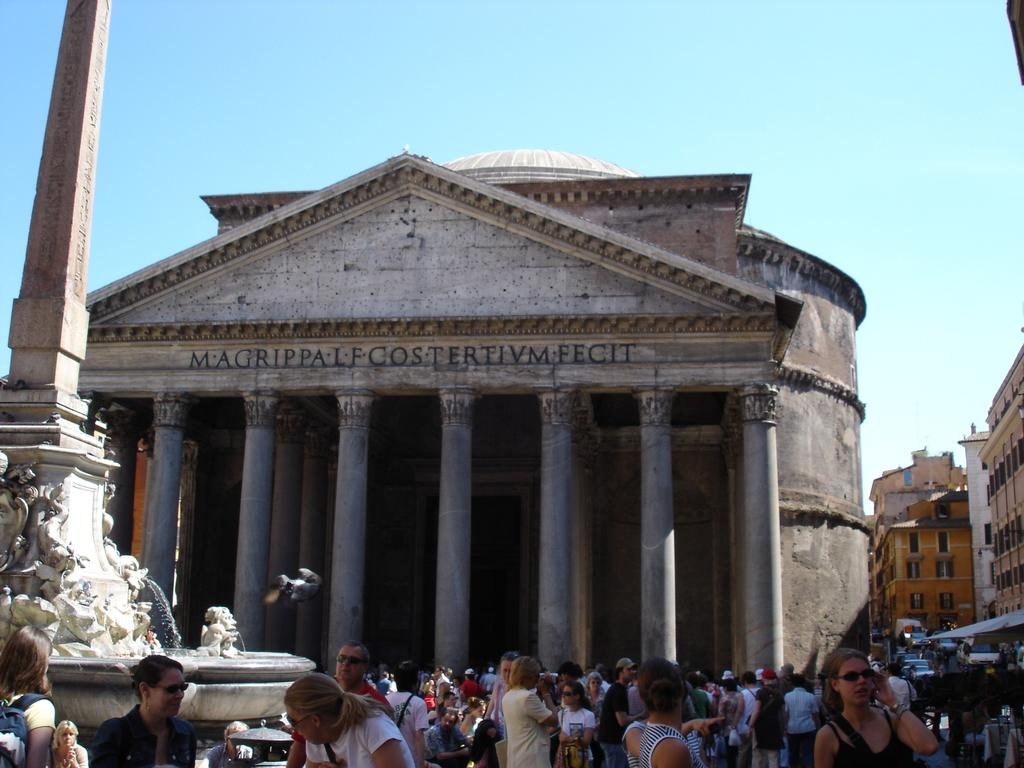What type of structures are present in the image? There are buildings with pillars in the image. What architectural features can be seen on the buildings? The buildings have windows. What is the color of the sky in the image? The sky is blue in the image. Can you describe the people in the image? There is a crowd visible in the image. What type of tin or lead can be seen in the image? There is no tin or lead present in the image. What mathematical operation is being performed by the crowd in the image? There is no indication of any mathematical operation being performed by the crowd in the image. 